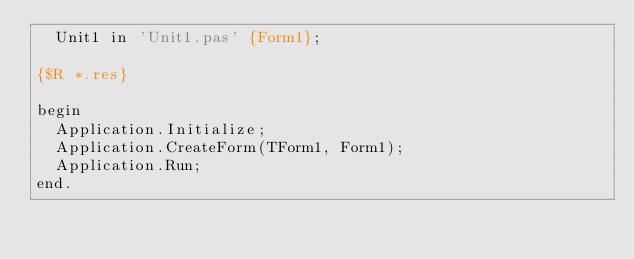Convert code to text. <code><loc_0><loc_0><loc_500><loc_500><_Pascal_>  Unit1 in 'Unit1.pas' {Form1};

{$R *.res}

begin
  Application.Initialize;
  Application.CreateForm(TForm1, Form1);
  Application.Run;
end.
</code> 